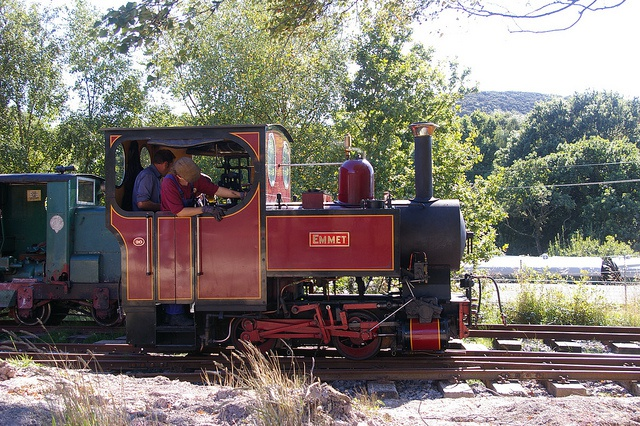Describe the objects in this image and their specific colors. I can see train in darkgray, black, maroon, brown, and gray tones, people in darkgray, maroon, black, and brown tones, and people in darkgray, black, navy, maroon, and purple tones in this image. 